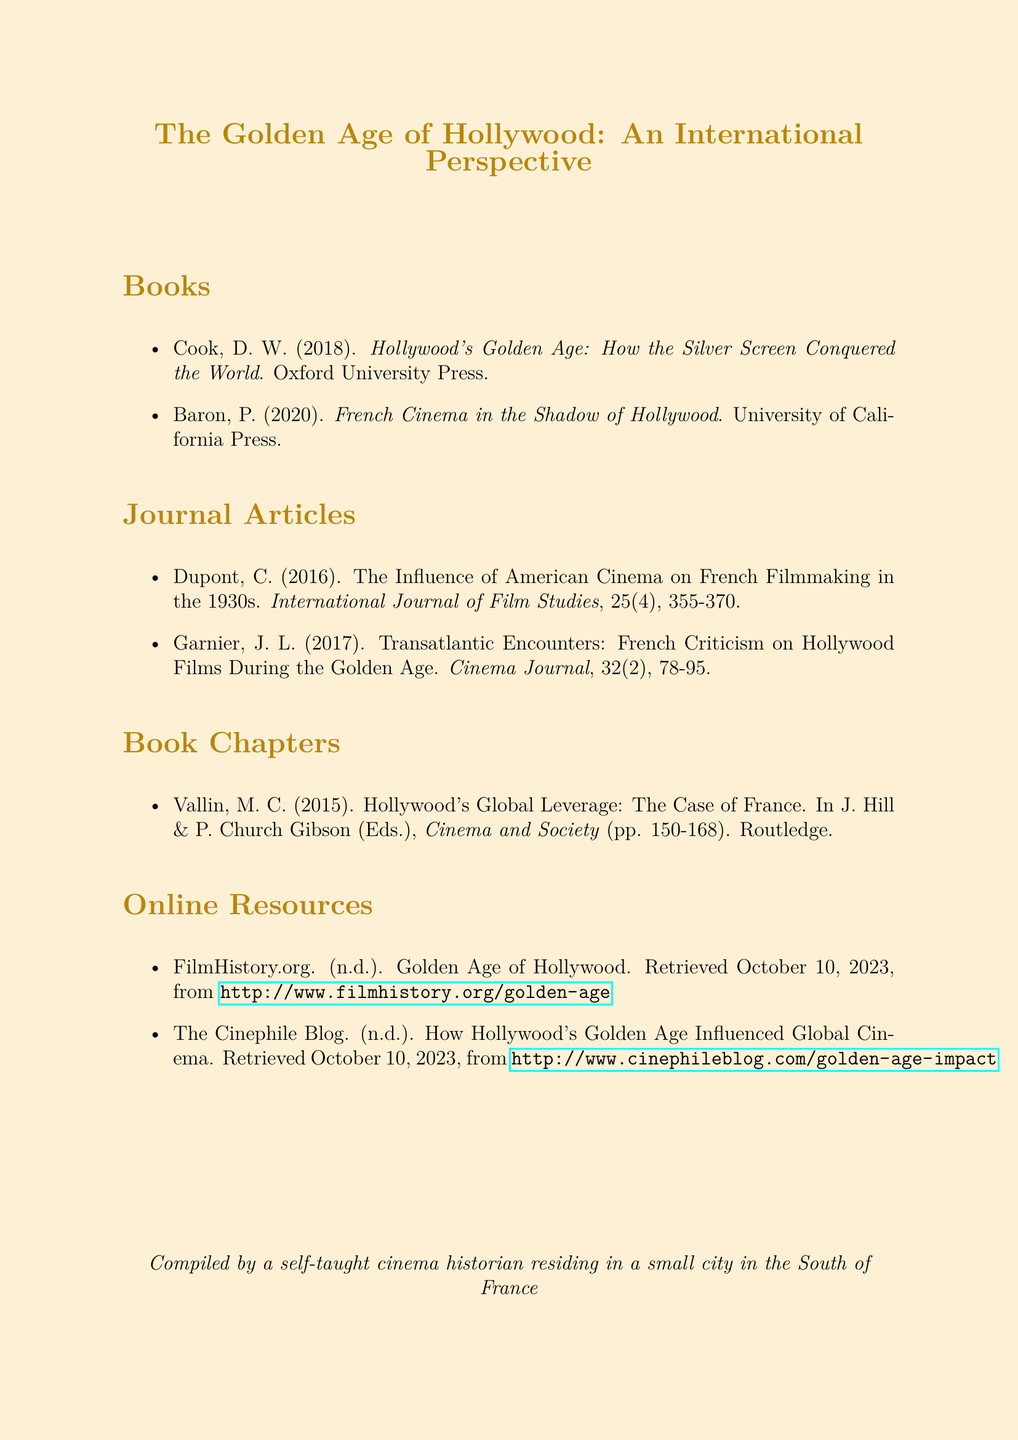What is the title of the first book listed? The title of the first book is the first item in the "Books" section.
Answer: Hollywood's Golden Age: How the Silver Screen Conquered the World Who is the author of the article regarding American cinema's influence on French filmmaking? The author of the article is in the "Journal Articles" section, focused on a specific topic.
Answer: Dupont, C In what year was "French Cinema in the Shadow of Hollywood" published? The publication year is part of the citation for the second book listed in the "Books" section.
Answer: 2020 How many journal articles are listed? The total number of journal articles can be counted in the "Journal Articles" section.
Answer: 2 What is the publisher of the book "Hollywood's Global Leverage: The Case of France"? The publisher is indicated in the citation format in the "Book Chapters" section.
Answer: Routledge What type of resource is "FilmHistory.org"? The type of resource is identified in the "Online Resources" section of the bibliography.
Answer: Online Resource Which chapter discusses Hollywood's Global Leverage? The chapter title is part of the "Book Chapters" section.
Answer: Hollywood's Global Leverage: The Case of France What is the URL for The Cinephile Blog resource? The URL is found in the "Online Resources" section for easy access.
Answer: http://www.cinephileblog.com/golden-age-impact 